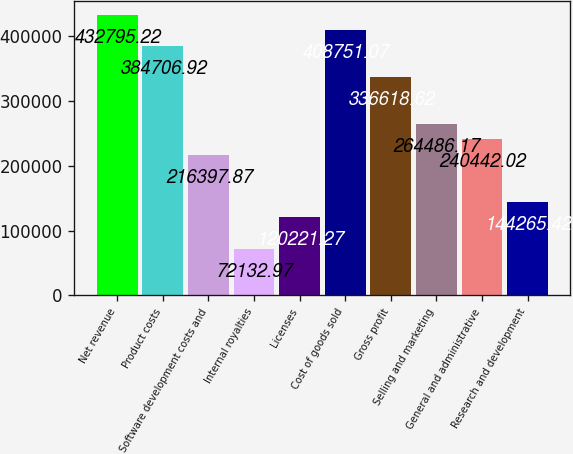<chart> <loc_0><loc_0><loc_500><loc_500><bar_chart><fcel>Net revenue<fcel>Product costs<fcel>Software development costs and<fcel>Internal royalties<fcel>Licenses<fcel>Cost of goods sold<fcel>Gross profit<fcel>Selling and marketing<fcel>General and administrative<fcel>Research and development<nl><fcel>432795<fcel>384707<fcel>216398<fcel>72133<fcel>120221<fcel>408751<fcel>336619<fcel>264486<fcel>240442<fcel>144265<nl></chart> 